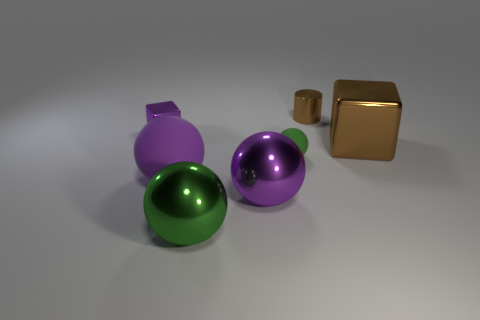What number of other big rubber spheres are the same color as the large rubber sphere?
Your response must be concise. 0. How many things are either large objects to the left of the tiny brown metal cylinder or tiny objects right of the large purple rubber ball?
Offer a very short reply. 5. There is a metallic object that is on the right side of the small brown object; how many large things are left of it?
Make the answer very short. 3. What color is the small cylinder that is the same material as the large brown object?
Offer a very short reply. Brown. Are there any shiny blocks that have the same size as the green metal ball?
Your answer should be compact. Yes. What is the shape of the brown object that is the same size as the purple matte ball?
Keep it short and to the point. Cube. Are there any small green metal things that have the same shape as the tiny brown metal thing?
Offer a very short reply. No. Is the small brown thing made of the same material as the block that is in front of the purple cube?
Offer a terse response. Yes. Are there any other cubes that have the same color as the small block?
Make the answer very short. No. How many other things are there of the same material as the small ball?
Give a very brief answer. 1. 